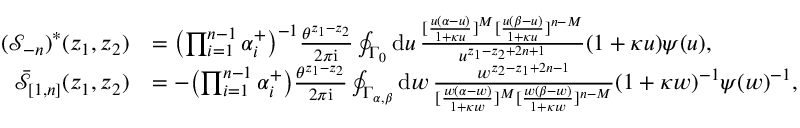Convert formula to latex. <formula><loc_0><loc_0><loc_500><loc_500>\begin{array} { r l } { ( \mathcal { S } _ { - n } ) ^ { * } ( z _ { 1 } , z _ { 2 } ) } & { = \left ( \prod _ { i = 1 } ^ { n - 1 } \alpha _ { i } ^ { + } \right ) ^ { - 1 } \frac { \theta ^ { z _ { 1 } - z _ { 2 } } } { 2 \pi i } \oint _ { \Gamma _ { 0 } } d u \, \frac { [ \frac { u ( \alpha - u ) } { 1 + \kappa u } ] ^ { M } [ \frac { u ( \beta - u ) } { 1 + \kappa u } ] ^ { n - M } } { u ^ { z _ { 1 } - z _ { 2 } + 2 n + 1 } } ( 1 + \kappa u ) \psi ( u ) , } \\ { \bar { \mathcal { S } } _ { [ 1 , n ] } ( z _ { 1 } , z _ { 2 } ) } & { = - \left ( \prod _ { i = 1 } ^ { n - 1 } \alpha _ { i } ^ { + } \right ) \frac { \theta ^ { z _ { 1 } - z _ { 2 } } } { 2 \pi i } \oint _ { \Gamma _ { \alpha , \beta } } d w \, \frac { w ^ { z _ { 2 } - z _ { 1 } + 2 n - 1 } } { [ \frac { w ( \alpha - w ) } { 1 + \kappa w } ] ^ { M } [ \frac { w ( \beta - w ) } { 1 + \kappa w } ] ^ { n - M } } ( 1 + \kappa w ) ^ { - 1 } \psi ( w ) ^ { - 1 } , } \end{array}</formula> 